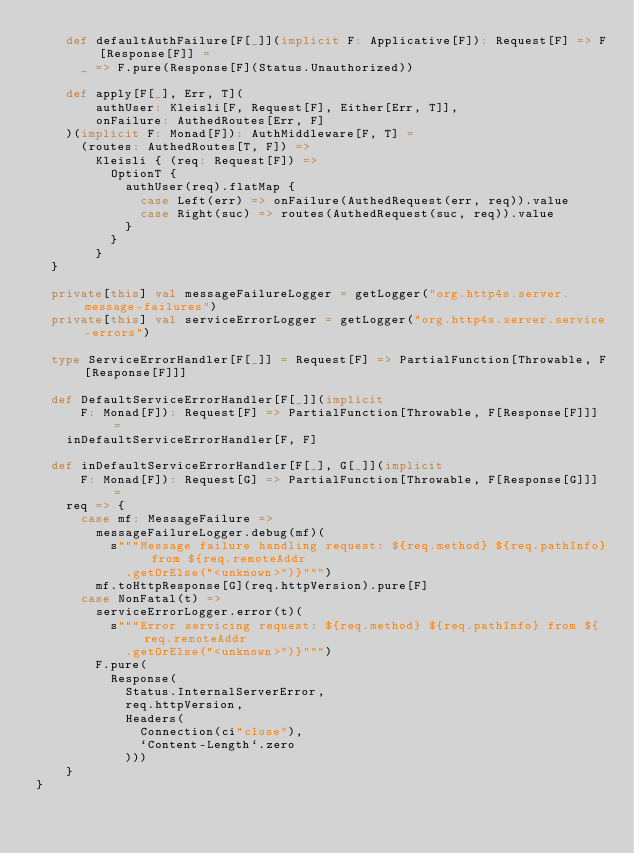<code> <loc_0><loc_0><loc_500><loc_500><_Scala_>    def defaultAuthFailure[F[_]](implicit F: Applicative[F]): Request[F] => F[Response[F]] =
      _ => F.pure(Response[F](Status.Unauthorized))

    def apply[F[_], Err, T](
        authUser: Kleisli[F, Request[F], Either[Err, T]],
        onFailure: AuthedRoutes[Err, F]
    )(implicit F: Monad[F]): AuthMiddleware[F, T] =
      (routes: AuthedRoutes[T, F]) =>
        Kleisli { (req: Request[F]) =>
          OptionT {
            authUser(req).flatMap {
              case Left(err) => onFailure(AuthedRequest(err, req)).value
              case Right(suc) => routes(AuthedRequest(suc, req)).value
            }
          }
        }
  }

  private[this] val messageFailureLogger = getLogger("org.http4s.server.message-failures")
  private[this] val serviceErrorLogger = getLogger("org.http4s.server.service-errors")

  type ServiceErrorHandler[F[_]] = Request[F] => PartialFunction[Throwable, F[Response[F]]]

  def DefaultServiceErrorHandler[F[_]](implicit
      F: Monad[F]): Request[F] => PartialFunction[Throwable, F[Response[F]]] =
    inDefaultServiceErrorHandler[F, F]

  def inDefaultServiceErrorHandler[F[_], G[_]](implicit
      F: Monad[F]): Request[G] => PartialFunction[Throwable, F[Response[G]]] =
    req => {
      case mf: MessageFailure =>
        messageFailureLogger.debug(mf)(
          s"""Message failure handling request: ${req.method} ${req.pathInfo} from ${req.remoteAddr
            .getOrElse("<unknown>")}""")
        mf.toHttpResponse[G](req.httpVersion).pure[F]
      case NonFatal(t) =>
        serviceErrorLogger.error(t)(
          s"""Error servicing request: ${req.method} ${req.pathInfo} from ${req.remoteAddr
            .getOrElse("<unknown>")}""")
        F.pure(
          Response(
            Status.InternalServerError,
            req.httpVersion,
            Headers(
              Connection(ci"close"),
              `Content-Length`.zero
            )))
    }
}
</code> 